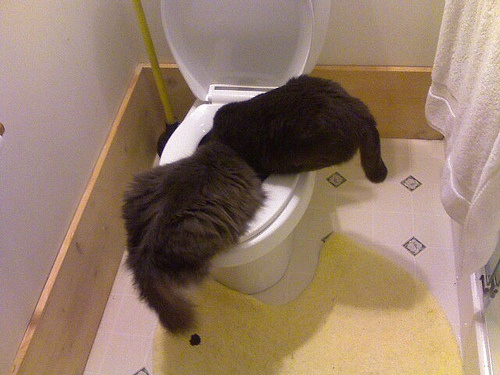Describe the objects in this image and their specific colors. I can see cat in lightpink, black, maroon, and gray tones and toilet in lightpink, gray, and lightgray tones in this image. 